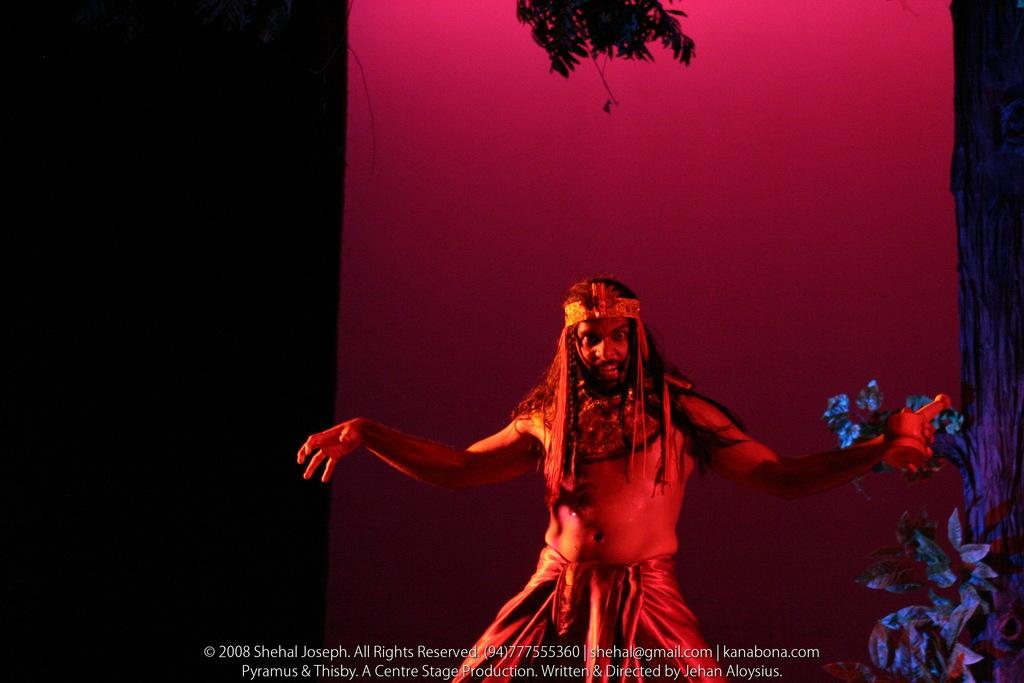What is the main subject in the middle of the image? There is a person in the middle of the image. What can be found at the bottom of the image? There is text at the bottom of the image. What type of natural element is on the right side of the image? There appears to be a tree on the right side of the image. Can you tell me how many divisions are present in the image? There is no mention of divisions in the image, so it cannot be determined from the provided facts. 